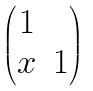Convert formula to latex. <formula><loc_0><loc_0><loc_500><loc_500>\begin{pmatrix} 1 & \\ x & 1 \end{pmatrix}</formula> 